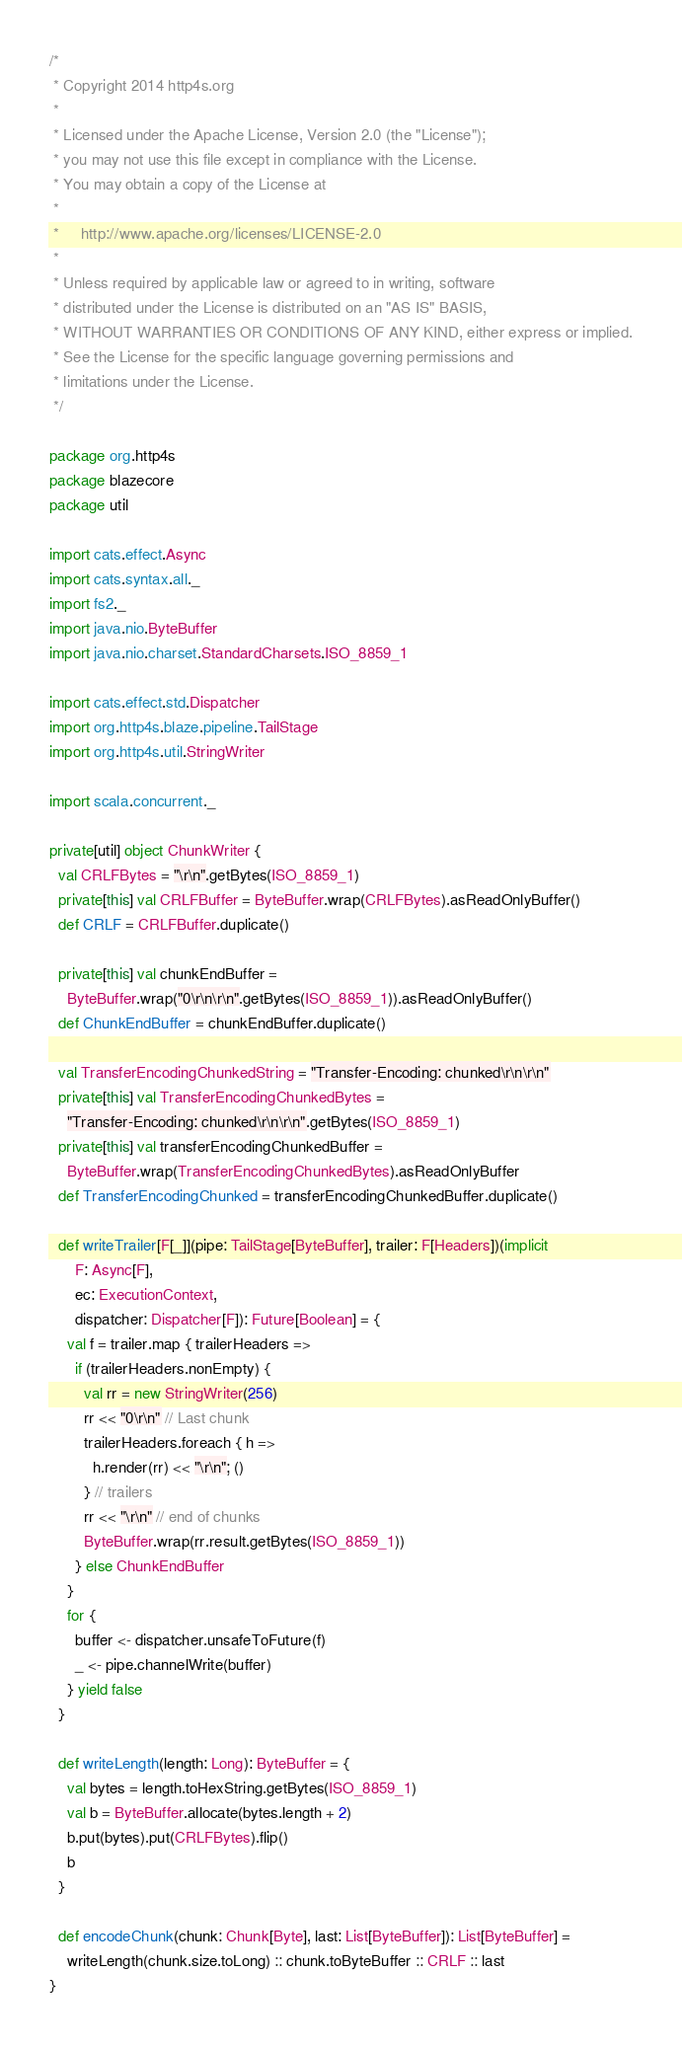Convert code to text. <code><loc_0><loc_0><loc_500><loc_500><_Scala_>/*
 * Copyright 2014 http4s.org
 *
 * Licensed under the Apache License, Version 2.0 (the "License");
 * you may not use this file except in compliance with the License.
 * You may obtain a copy of the License at
 *
 *     http://www.apache.org/licenses/LICENSE-2.0
 *
 * Unless required by applicable law or agreed to in writing, software
 * distributed under the License is distributed on an "AS IS" BASIS,
 * WITHOUT WARRANTIES OR CONDITIONS OF ANY KIND, either express or implied.
 * See the License for the specific language governing permissions and
 * limitations under the License.
 */

package org.http4s
package blazecore
package util

import cats.effect.Async
import cats.syntax.all._
import fs2._
import java.nio.ByteBuffer
import java.nio.charset.StandardCharsets.ISO_8859_1

import cats.effect.std.Dispatcher
import org.http4s.blaze.pipeline.TailStage
import org.http4s.util.StringWriter

import scala.concurrent._

private[util] object ChunkWriter {
  val CRLFBytes = "\r\n".getBytes(ISO_8859_1)
  private[this] val CRLFBuffer = ByteBuffer.wrap(CRLFBytes).asReadOnlyBuffer()
  def CRLF = CRLFBuffer.duplicate()

  private[this] val chunkEndBuffer =
    ByteBuffer.wrap("0\r\n\r\n".getBytes(ISO_8859_1)).asReadOnlyBuffer()
  def ChunkEndBuffer = chunkEndBuffer.duplicate()

  val TransferEncodingChunkedString = "Transfer-Encoding: chunked\r\n\r\n"
  private[this] val TransferEncodingChunkedBytes =
    "Transfer-Encoding: chunked\r\n\r\n".getBytes(ISO_8859_1)
  private[this] val transferEncodingChunkedBuffer =
    ByteBuffer.wrap(TransferEncodingChunkedBytes).asReadOnlyBuffer
  def TransferEncodingChunked = transferEncodingChunkedBuffer.duplicate()

  def writeTrailer[F[_]](pipe: TailStage[ByteBuffer], trailer: F[Headers])(implicit
      F: Async[F],
      ec: ExecutionContext,
      dispatcher: Dispatcher[F]): Future[Boolean] = {
    val f = trailer.map { trailerHeaders =>
      if (trailerHeaders.nonEmpty) {
        val rr = new StringWriter(256)
        rr << "0\r\n" // Last chunk
        trailerHeaders.foreach { h =>
          h.render(rr) << "\r\n"; ()
        } // trailers
        rr << "\r\n" // end of chunks
        ByteBuffer.wrap(rr.result.getBytes(ISO_8859_1))
      } else ChunkEndBuffer
    }
    for {
      buffer <- dispatcher.unsafeToFuture(f)
      _ <- pipe.channelWrite(buffer)
    } yield false
  }

  def writeLength(length: Long): ByteBuffer = {
    val bytes = length.toHexString.getBytes(ISO_8859_1)
    val b = ByteBuffer.allocate(bytes.length + 2)
    b.put(bytes).put(CRLFBytes).flip()
    b
  }

  def encodeChunk(chunk: Chunk[Byte], last: List[ByteBuffer]): List[ByteBuffer] =
    writeLength(chunk.size.toLong) :: chunk.toByteBuffer :: CRLF :: last
}
</code> 